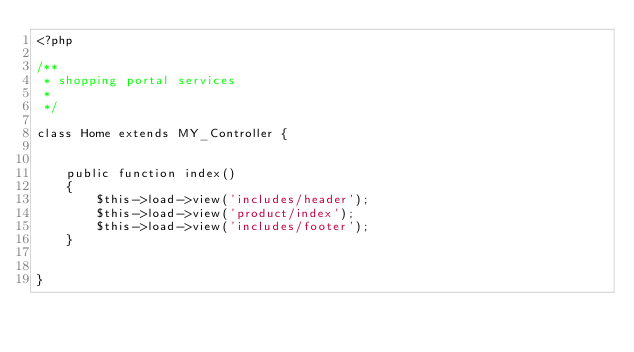<code> <loc_0><loc_0><loc_500><loc_500><_PHP_><?php

/**
 * shopping portal services
 * 
 */

class Home extends MY_Controller {


	public function index()
	{
		$this->load->view('includes/header');
		$this->load->view('product/index');
		$this->load->view('includes/footer');
	}


}
</code> 